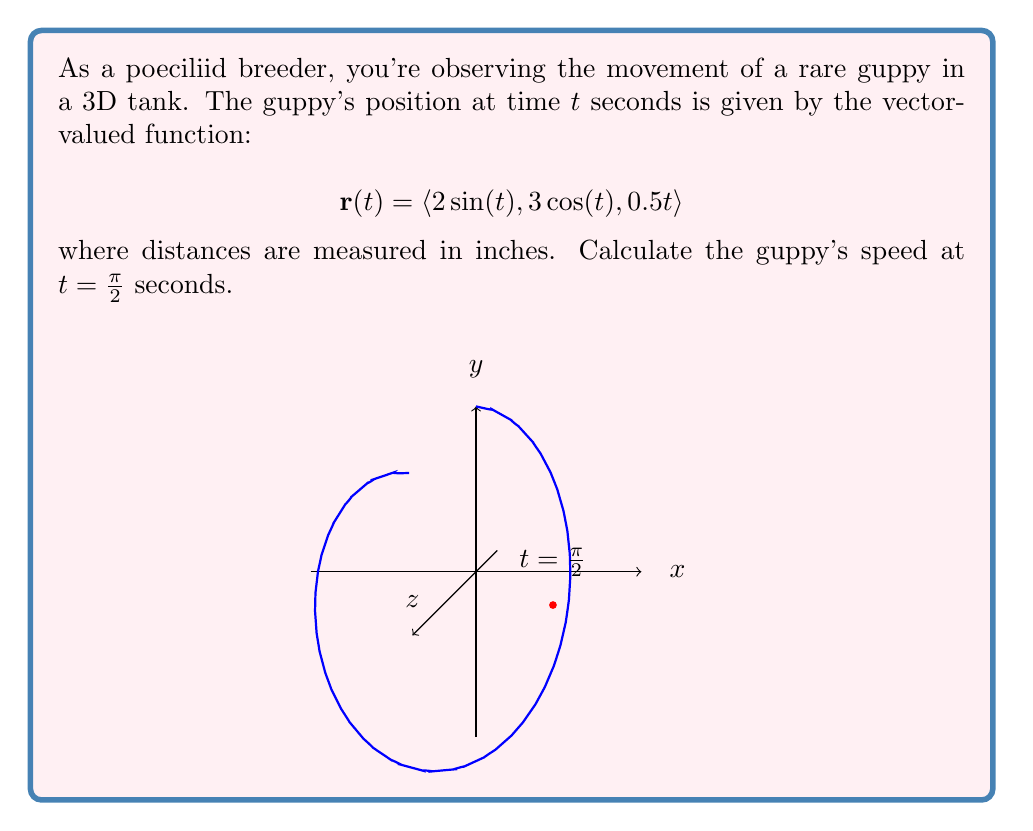Can you answer this question? Let's approach this step-by-step:

1) The speed of an object is the magnitude of its velocity vector. For a vector-valued function $\mathbf{r}(t)$, the velocity vector is given by $\mathbf{v}(t) = \mathbf{r}'(t)$.

2) Let's find $\mathbf{r}'(t)$:
   $$\mathbf{r}'(t) = \langle 2\cos(t), -3\sin(t), 0.5 \rangle$$

3) Now, we need to evaluate this at $t = \frac{\pi}{2}$:
   $$\mathbf{v}(\frac{\pi}{2}) = \langle 2\cos(\frac{\pi}{2}), -3\sin(\frac{\pi}{2}), 0.5 \rangle$$

4) Simplify:
   $$\mathbf{v}(\frac{\pi}{2}) = \langle 0, -3, 0.5 \rangle$$

5) The speed is the magnitude of this vector. We can calculate it using the formula:
   $$\text{speed} = \sqrt{x^2 + y^2 + z^2}$$

6) Substituting our values:
   $$\text{speed} = \sqrt{0^2 + (-3)^2 + 0.5^2}$$

7) Simplify:
   $$\text{speed} = \sqrt{9 + 0.25} = \sqrt{9.25} = \frac{\sqrt{37}}{2}$$

Therefore, the guppy's speed at $t = \frac{\pi}{2}$ seconds is $\frac{\sqrt{37}}{2}$ inches per second.
Answer: $\frac{\sqrt{37}}{2}$ in/s 